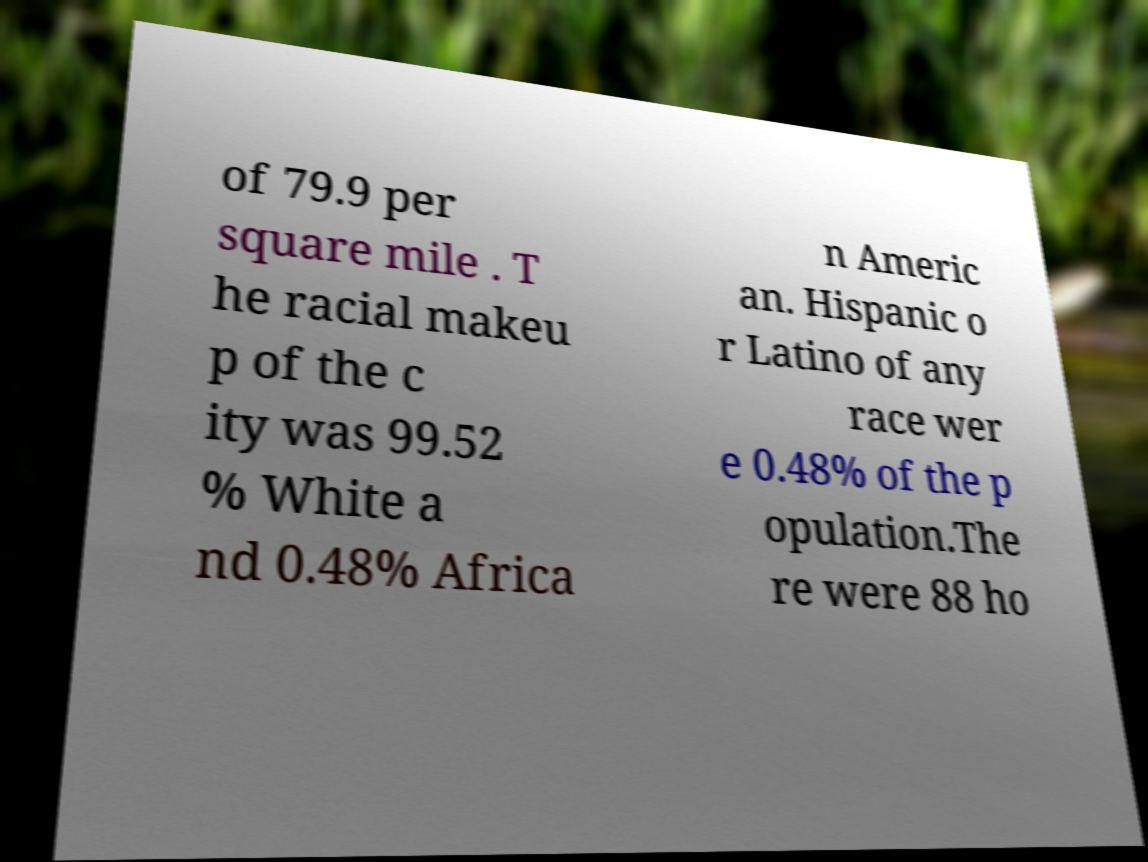For documentation purposes, I need the text within this image transcribed. Could you provide that? of 79.9 per square mile . T he racial makeu p of the c ity was 99.52 % White a nd 0.48% Africa n Americ an. Hispanic o r Latino of any race wer e 0.48% of the p opulation.The re were 88 ho 